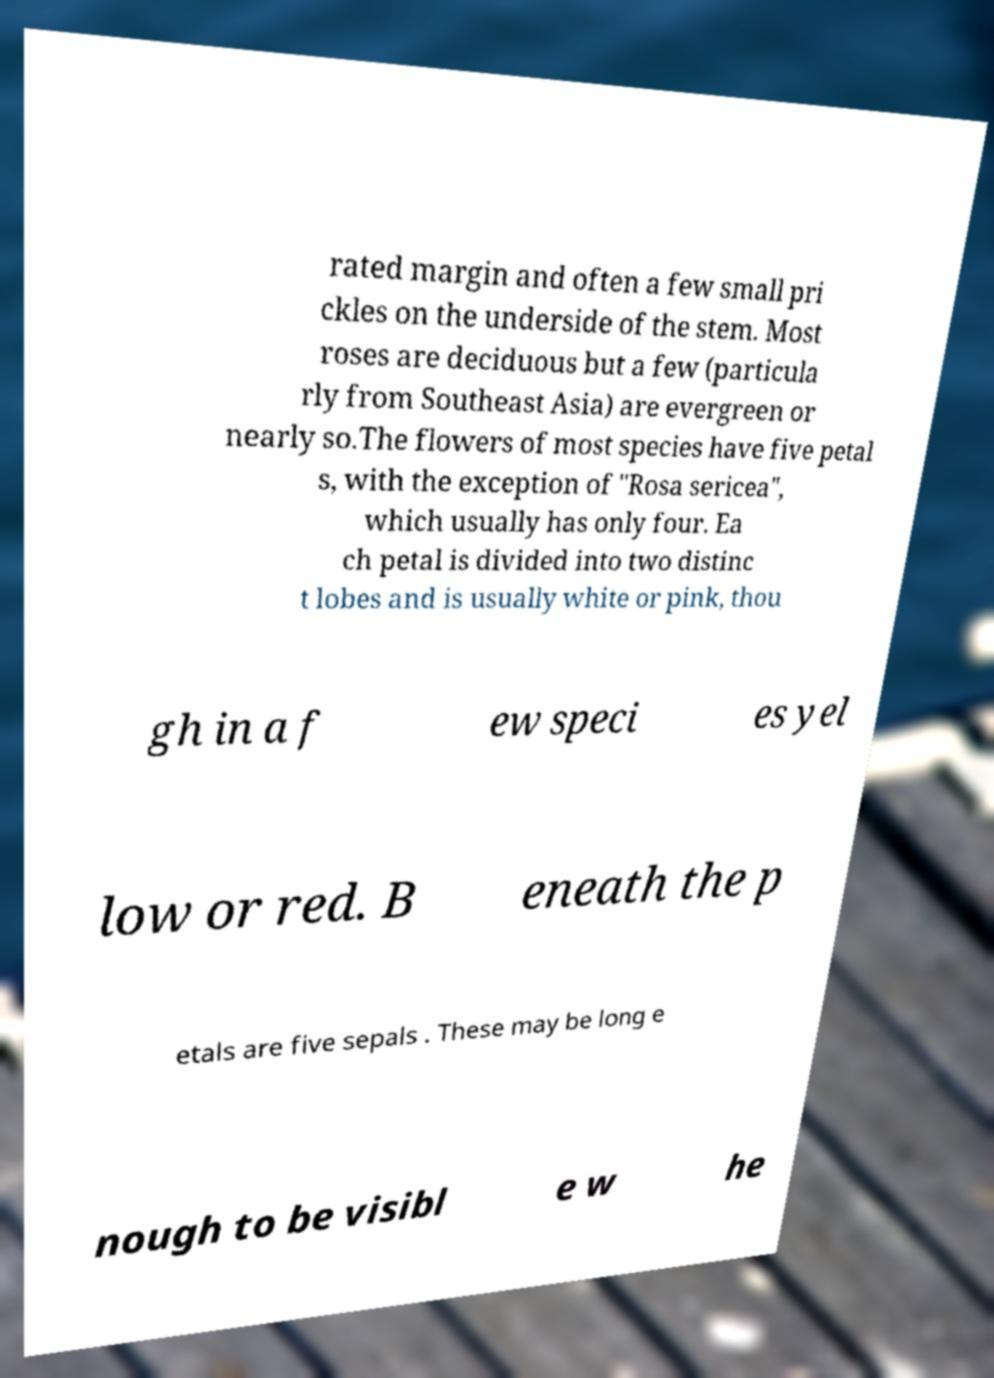Please identify and transcribe the text found in this image. rated margin and often a few small pri ckles on the underside of the stem. Most roses are deciduous but a few (particula rly from Southeast Asia) are evergreen or nearly so.The flowers of most species have five petal s, with the exception of "Rosa sericea", which usually has only four. Ea ch petal is divided into two distinc t lobes and is usually white or pink, thou gh in a f ew speci es yel low or red. B eneath the p etals are five sepals . These may be long e nough to be visibl e w he 